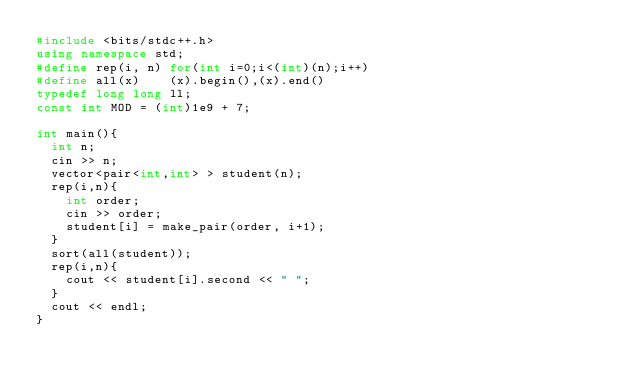Convert code to text. <code><loc_0><loc_0><loc_500><loc_500><_C++_>#include <bits/stdc++.h>
using namespace std;
#define rep(i, n) for(int i=0;i<(int)(n);i++)
#define all(x)    (x).begin(),(x).end()
typedef long long ll;
const int MOD = (int)1e9 + 7;

int main(){
  int n;
  cin >> n;
  vector<pair<int,int> > student(n);
  rep(i,n){
    int order;
    cin >> order;
    student[i] = make_pair(order, i+1);
  }
  sort(all(student));
  rep(i,n){
    cout << student[i].second << " ";
  }
  cout << endl;
}

</code> 